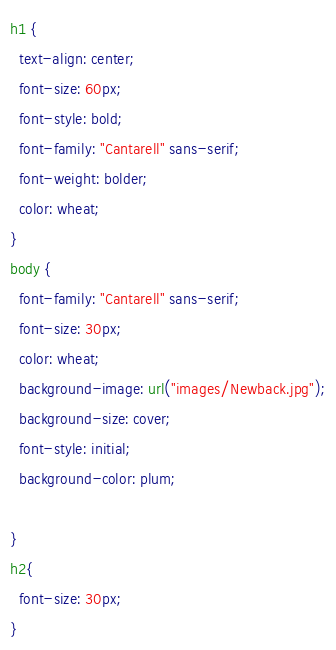Convert code to text. <code><loc_0><loc_0><loc_500><loc_500><_CSS_>h1 {
  text-align: center;
  font-size: 60px;
  font-style: bold;
  font-family: "Cantarell" sans-serif;
  font-weight: bolder;
  color: wheat;
}
body {
  font-family: "Cantarell" sans-serif;
  font-size: 30px;
  color: wheat;
  background-image: url("images/Newback.jpg");
  background-size: cover;
  font-style: initial;
  background-color: plum; 

}
h2{
  font-size: 30px;
}</code> 